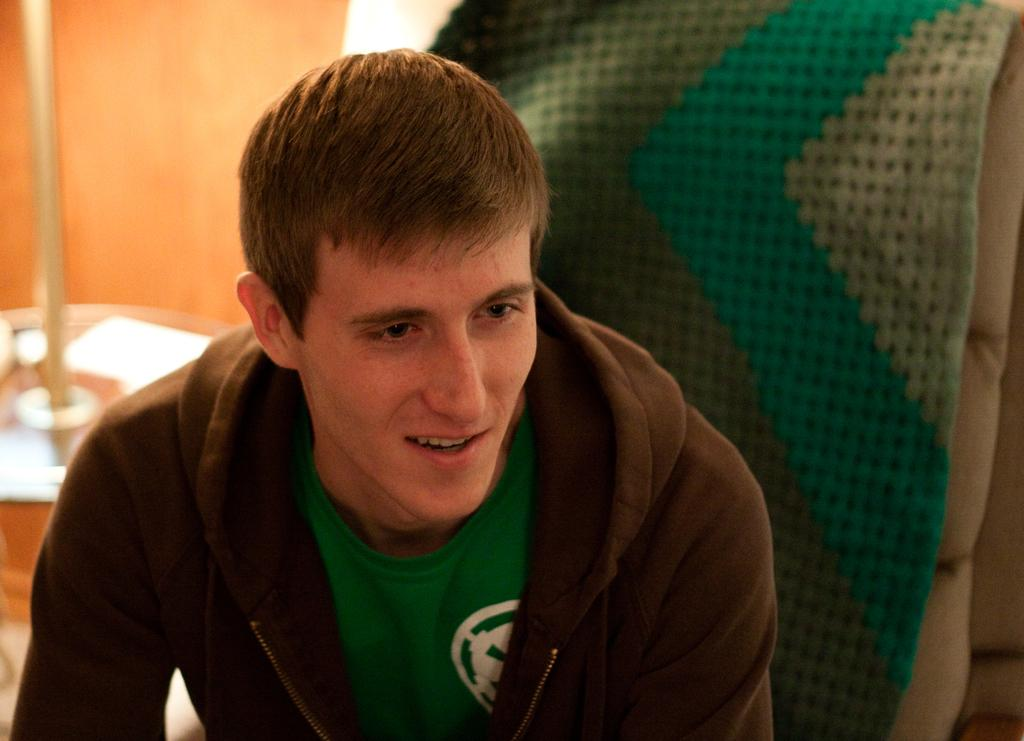What is the man in the image doing? The man is sitting in the image. What type of clothing is the man wearing on top? The man is wearing a hoodie. What color is the hoodie? The hoodie is green in color. What type of shirt is the man wearing underneath the hoodie? The man is wearing a t-shirt underneath the hoodie. What is the man sitting on in the image? There is a chair behind the man. What sound does the man make when he starts to get angry in the image? There is no indication in the image that the man is getting angry or making any sounds. 